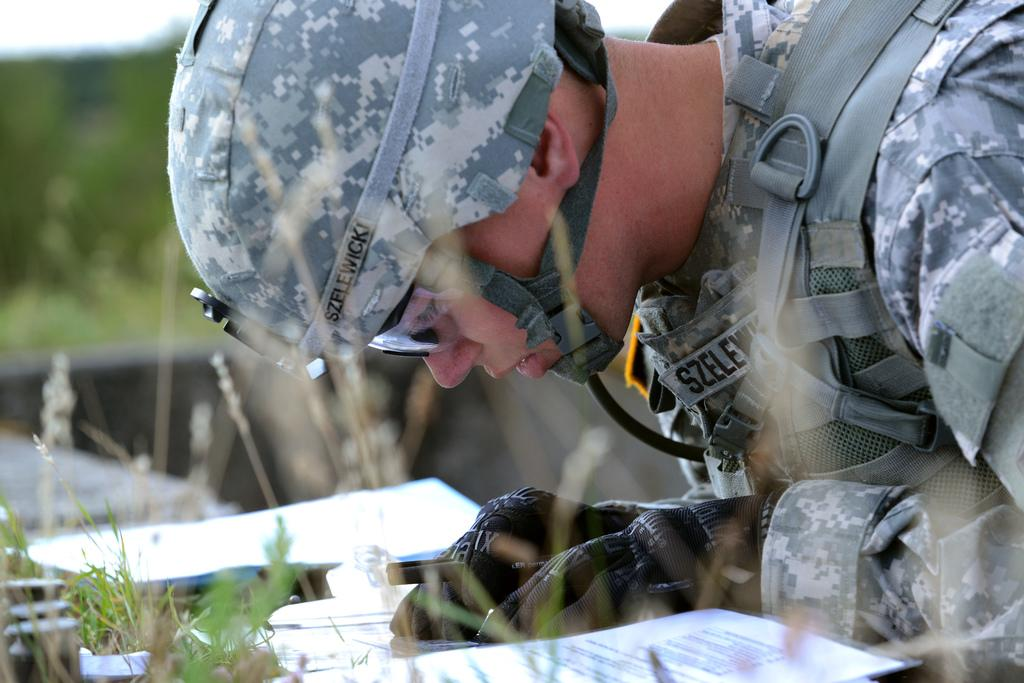What is the main subject of the image? There is a person in the image. What is the person wearing? The person is wearing a uniform. What type of coil is the person holding in the image? There is no coil present in the image; the person is simply wearing a uniform. 